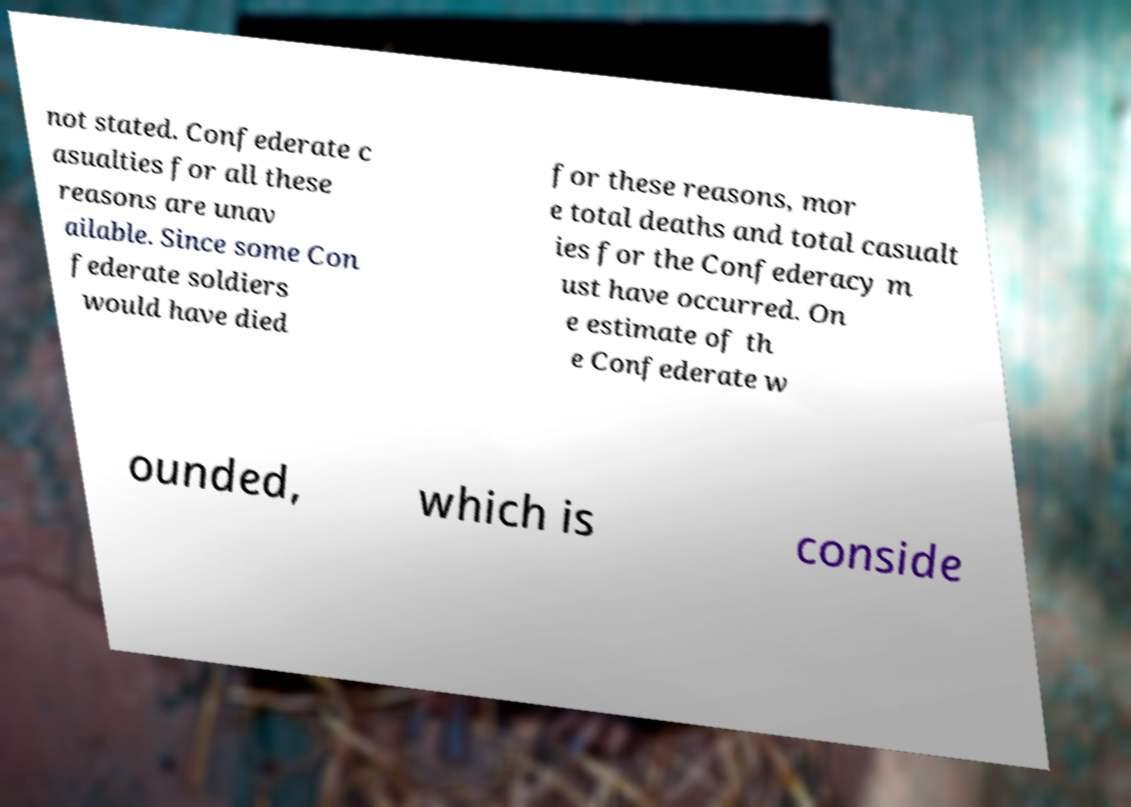For documentation purposes, I need the text within this image transcribed. Could you provide that? not stated. Confederate c asualties for all these reasons are unav ailable. Since some Con federate soldiers would have died for these reasons, mor e total deaths and total casualt ies for the Confederacy m ust have occurred. On e estimate of th e Confederate w ounded, which is conside 